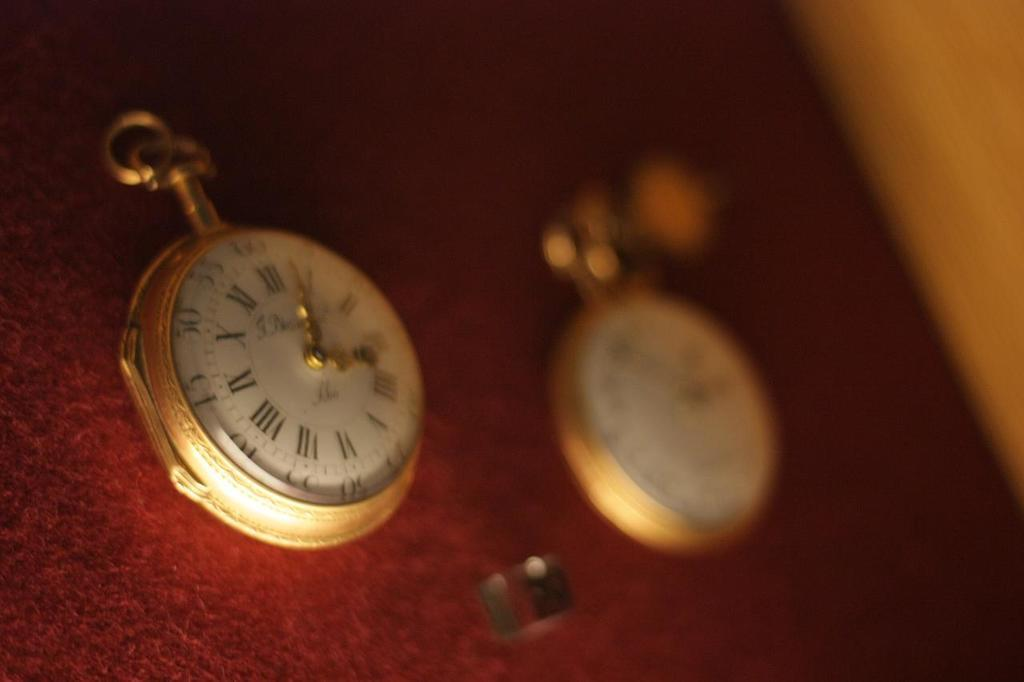<image>
Describe the image concisely. A gold watch on the left with numbers and Roman numerals has a time of 3:04. 